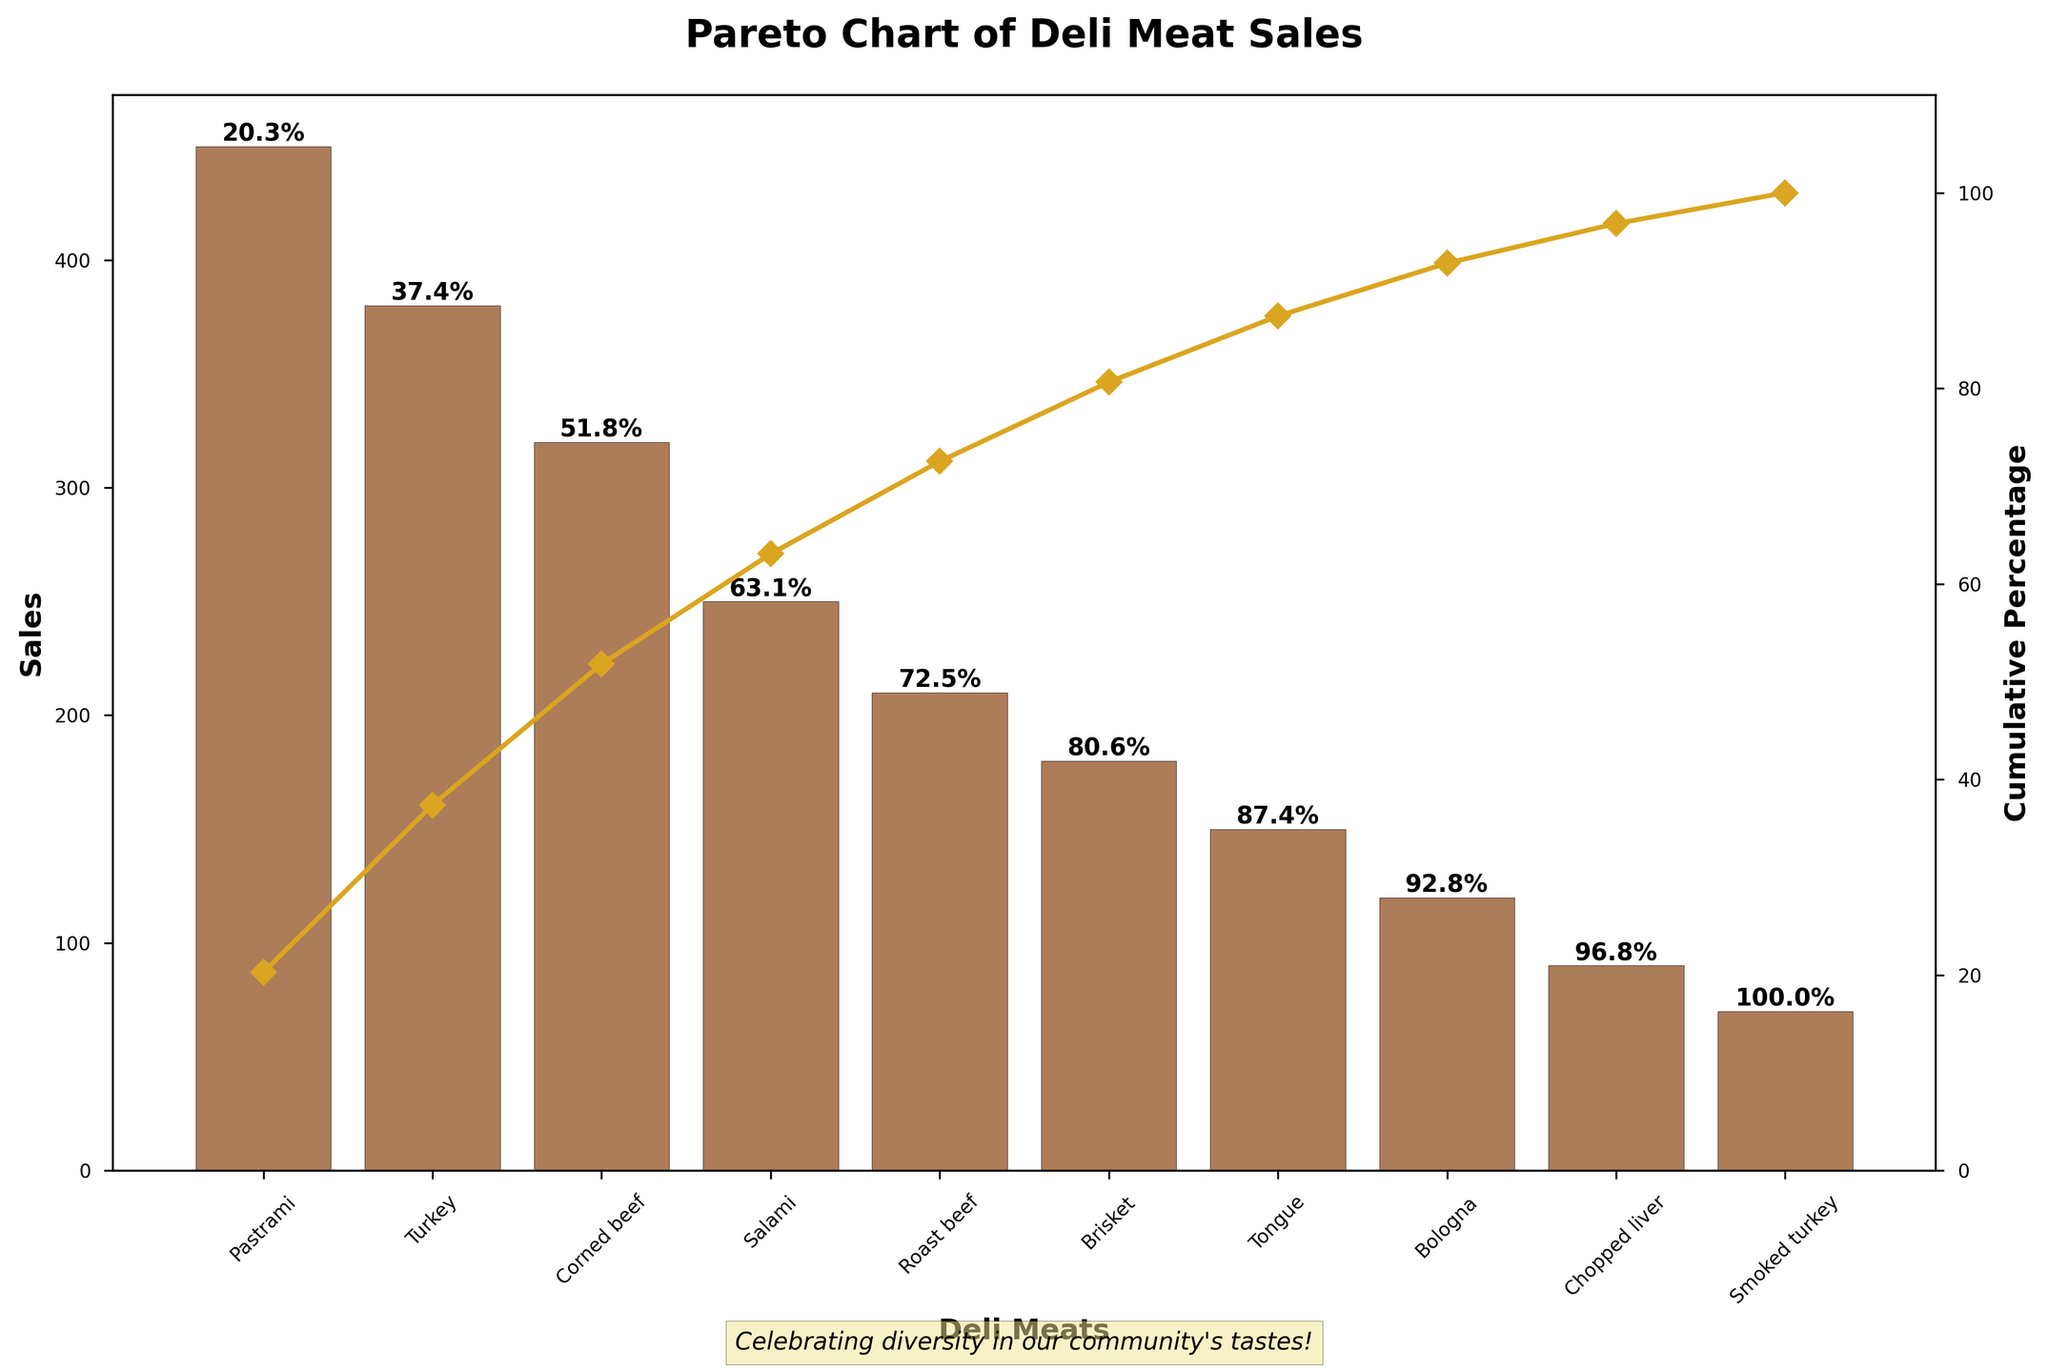Which deli meat has the highest sales? The figure shows a bar chart of deli meat sales, and the bar representing Pastrami is the tallest. Pastrami sales amount to 450, making it the most popular deli meat.
Answer: Pastrami What is the cumulative percentage of sales for Pastrami, Turkey, and Corned Beef combined? The cumulative percentages for Pastrami, Turkey, and Corned Beef are shown on the chart. Adding them, Pastrami (38.2%) + Turkey (69.4%) + Corned Beef (96.5%) = 96.5%.
Answer: 96.5% Which two deli meats have the closest sales numbers? By comparing the heights of the bars, Brisket (180) and Tongue (150) have sales numbers close to each other. The difference is 180 - 150 = 30.
Answer: Brisket and Tongue How much higher are Pastrami sales compared to Smoked Turkey sales? Pastrami's sales are 450 and Smoked Turkey's are 70. The difference is calculated by subtracting 70 from 450: 450 - 70 = 380.
Answer: 380 How many deli meats contribute to approximately 80% of total sales? Following the cumulative percentages along the second y-axis, we can see that approximately 80% of total sales is reached after the first four deli meats (Pastrami, Turkey, Corned Beef, and Salami).
Answer: 4 Which deli meat shows the smallest sales contribution? The shortest bar on the bar chart represents Smoked Turkey, indicating it has the lowest sales of 70.
Answer: Smoked Turkey What is the cumulative percentage after adding Salami's sales to the total? The cumulative percentage after Salami is shown on the chart as approximately 79.8%.
Answer: 79.8% What is the difference in cumulative percentage between Roast Beef and Tongue? The cumulative percentage for Roast Beef is about 85.3%, and for Tongue, it is approximately 99.4%. The difference is 99.4% - 85.3% = 14.1%.
Answer: 14.1% 